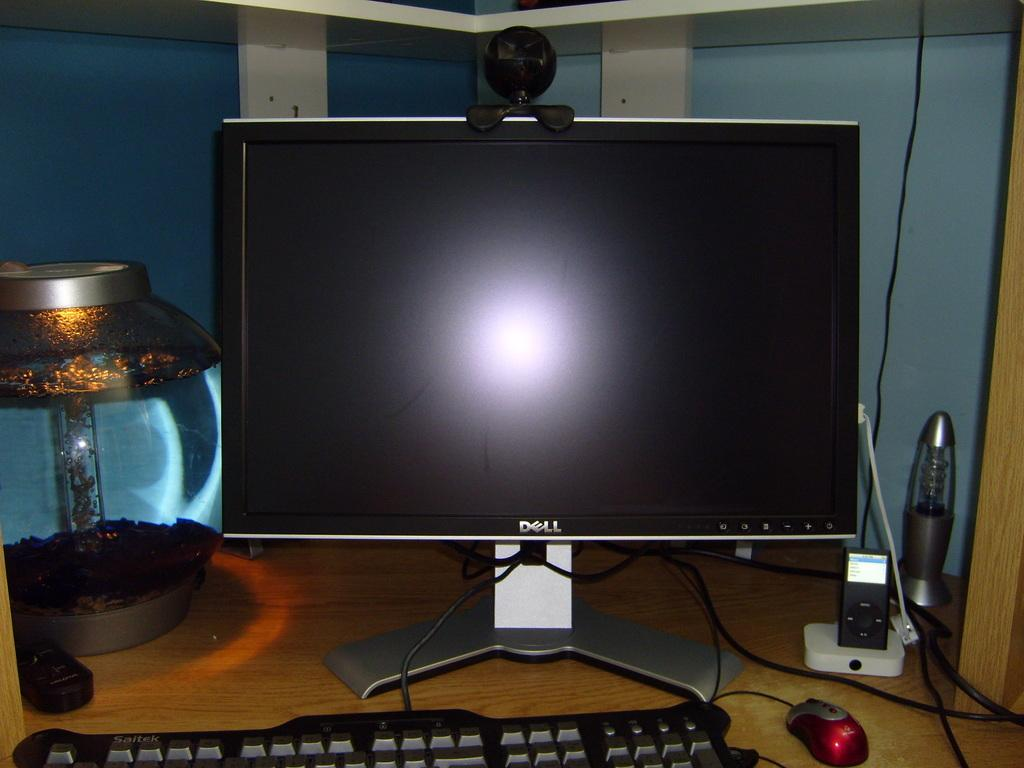<image>
Write a terse but informative summary of the picture. Dell computer monitor with a reflection sitting on a desk with light keyboard and mouse. 